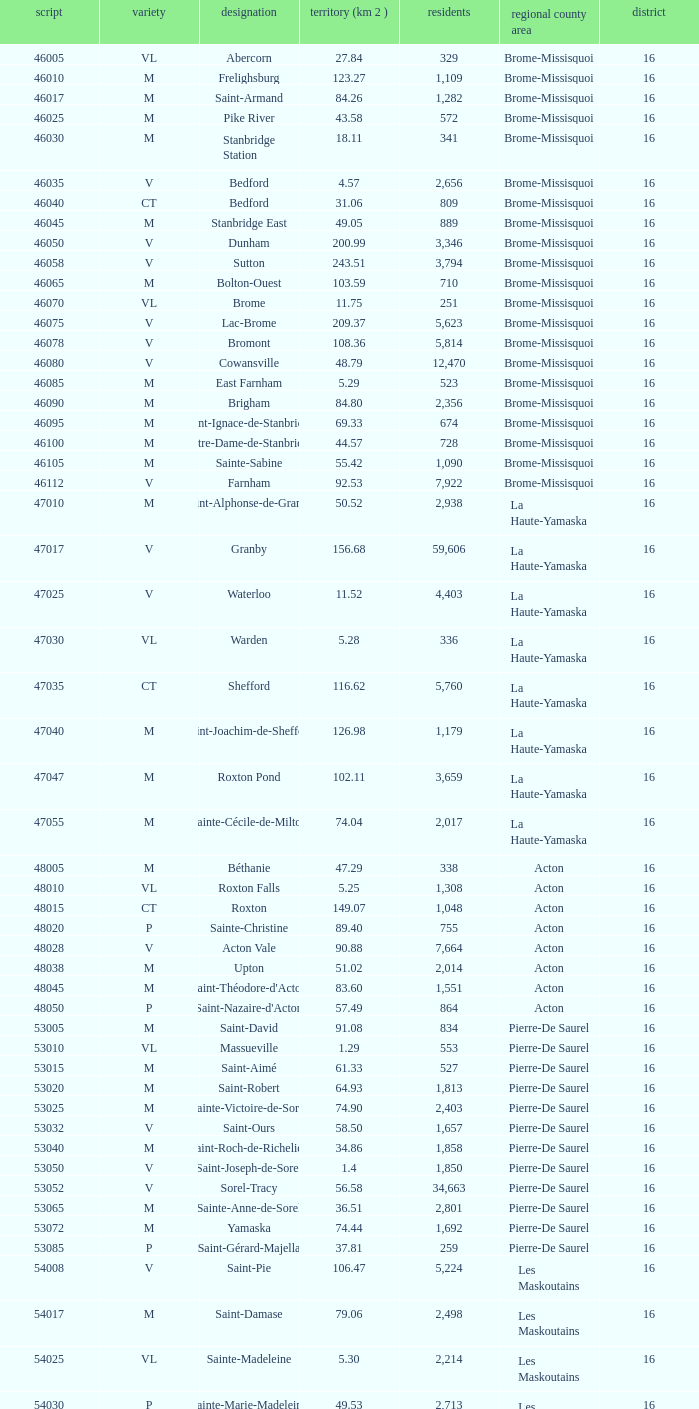Saint-Blaise-Sur-Richelieu is smaller than 68.42 km^2, what is the population of this type M municipality? None. 